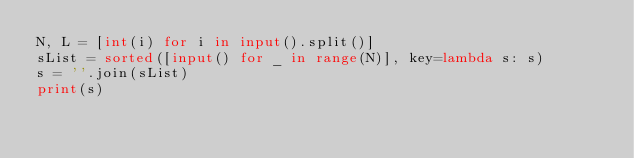Convert code to text. <code><loc_0><loc_0><loc_500><loc_500><_Python_>N, L = [int(i) for i in input().split()]
sList = sorted([input() for _ in range(N)], key=lambda s: s)
s = ''.join(sList)
print(s)</code> 